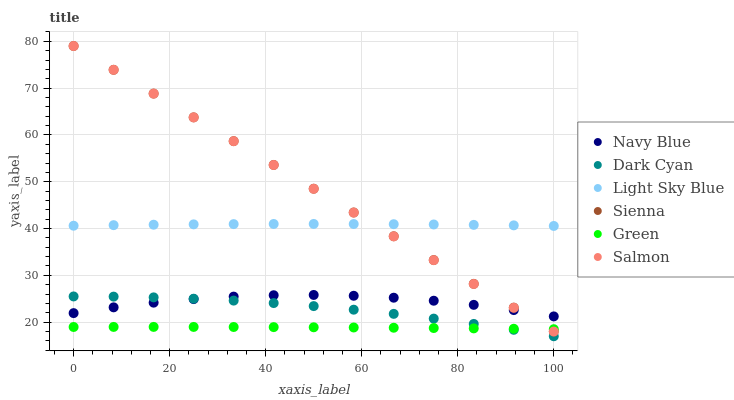Does Green have the minimum area under the curve?
Answer yes or no. Yes. Does Sienna have the maximum area under the curve?
Answer yes or no. Yes. Does Salmon have the minimum area under the curve?
Answer yes or no. No. Does Salmon have the maximum area under the curve?
Answer yes or no. No. Is Sienna the smoothest?
Answer yes or no. Yes. Is Navy Blue the roughest?
Answer yes or no. Yes. Is Salmon the smoothest?
Answer yes or no. No. Is Salmon the roughest?
Answer yes or no. No. Does Dark Cyan have the lowest value?
Answer yes or no. Yes. Does Salmon have the lowest value?
Answer yes or no. No. Does Sienna have the highest value?
Answer yes or no. Yes. Does Light Sky Blue have the highest value?
Answer yes or no. No. Is Dark Cyan less than Sienna?
Answer yes or no. Yes. Is Light Sky Blue greater than Green?
Answer yes or no. Yes. Does Navy Blue intersect Salmon?
Answer yes or no. Yes. Is Navy Blue less than Salmon?
Answer yes or no. No. Is Navy Blue greater than Salmon?
Answer yes or no. No. Does Dark Cyan intersect Sienna?
Answer yes or no. No. 